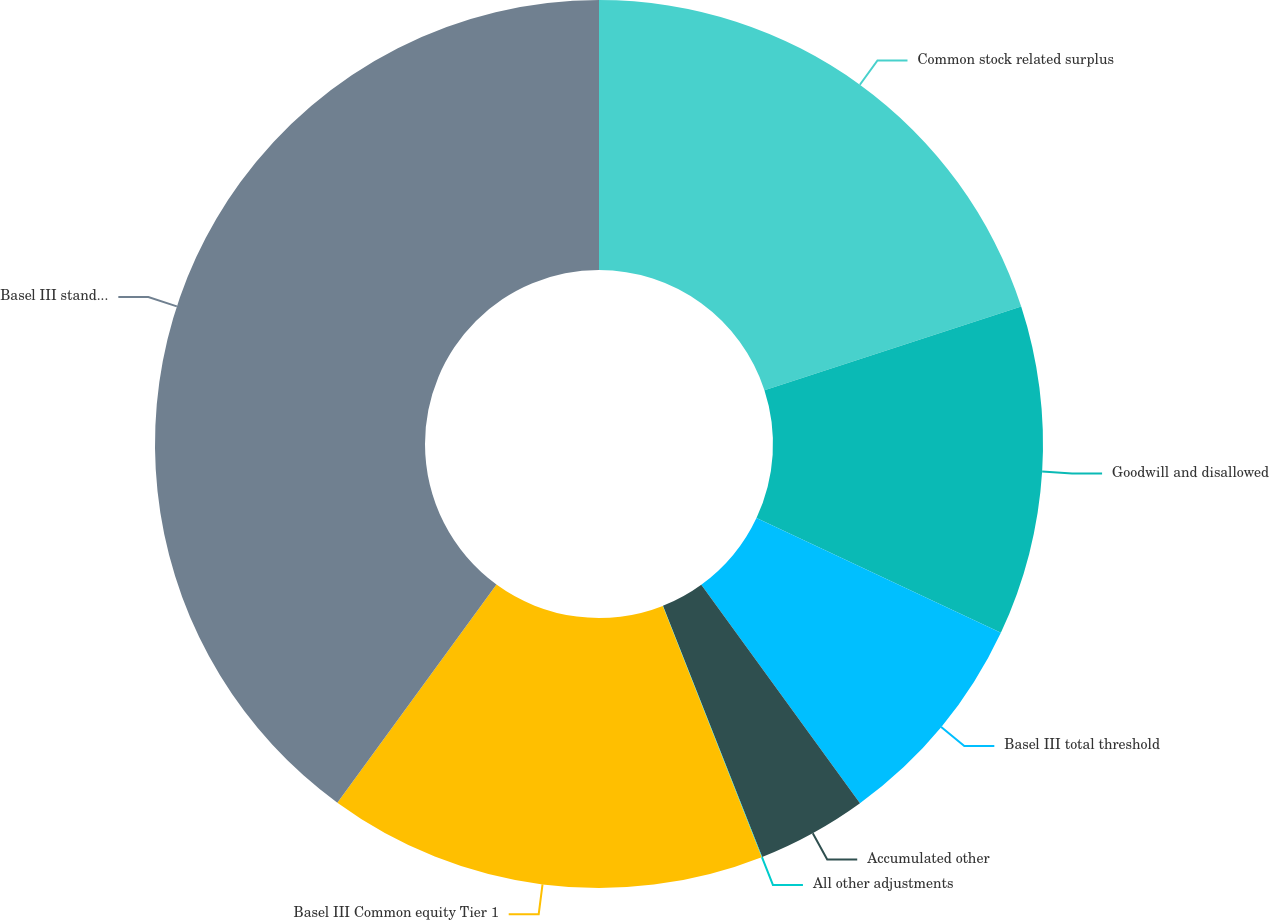Convert chart to OTSL. <chart><loc_0><loc_0><loc_500><loc_500><pie_chart><fcel>Common stock related surplus<fcel>Goodwill and disallowed<fcel>Basel III total threshold<fcel>Accumulated other<fcel>All other adjustments<fcel>Basel III Common equity Tier 1<fcel>Basel III standardized<nl><fcel>19.99%<fcel>12.0%<fcel>8.01%<fcel>4.01%<fcel>0.02%<fcel>16.0%<fcel>39.97%<nl></chart> 